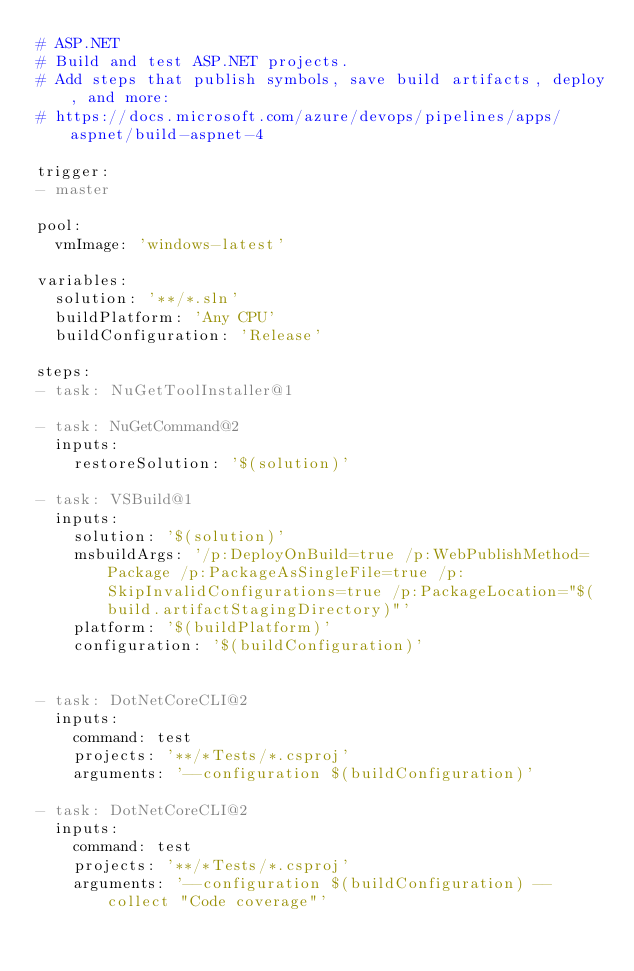Convert code to text. <code><loc_0><loc_0><loc_500><loc_500><_YAML_># ASP.NET
# Build and test ASP.NET projects.
# Add steps that publish symbols, save build artifacts, deploy, and more:
# https://docs.microsoft.com/azure/devops/pipelines/apps/aspnet/build-aspnet-4

trigger:
- master

pool:
  vmImage: 'windows-latest'

variables:
  solution: '**/*.sln'
  buildPlatform: 'Any CPU'
  buildConfiguration: 'Release'

steps:
- task: NuGetToolInstaller@1

- task: NuGetCommand@2
  inputs:
    restoreSolution: '$(solution)'

- task: VSBuild@1
  inputs:
    solution: '$(solution)'
    msbuildArgs: '/p:DeployOnBuild=true /p:WebPublishMethod=Package /p:PackageAsSingleFile=true /p:SkipInvalidConfigurations=true /p:PackageLocation="$(build.artifactStagingDirectory)"'
    platform: '$(buildPlatform)'
    configuration: '$(buildConfiguration)'


- task: DotNetCoreCLI@2
  inputs:
    command: test
    projects: '**/*Tests/*.csproj'
    arguments: '--configuration $(buildConfiguration)'

- task: DotNetCoreCLI@2
  inputs:
    command: test
    projects: '**/*Tests/*.csproj'
    arguments: '--configuration $(buildConfiguration) --collect "Code coverage"'</code> 